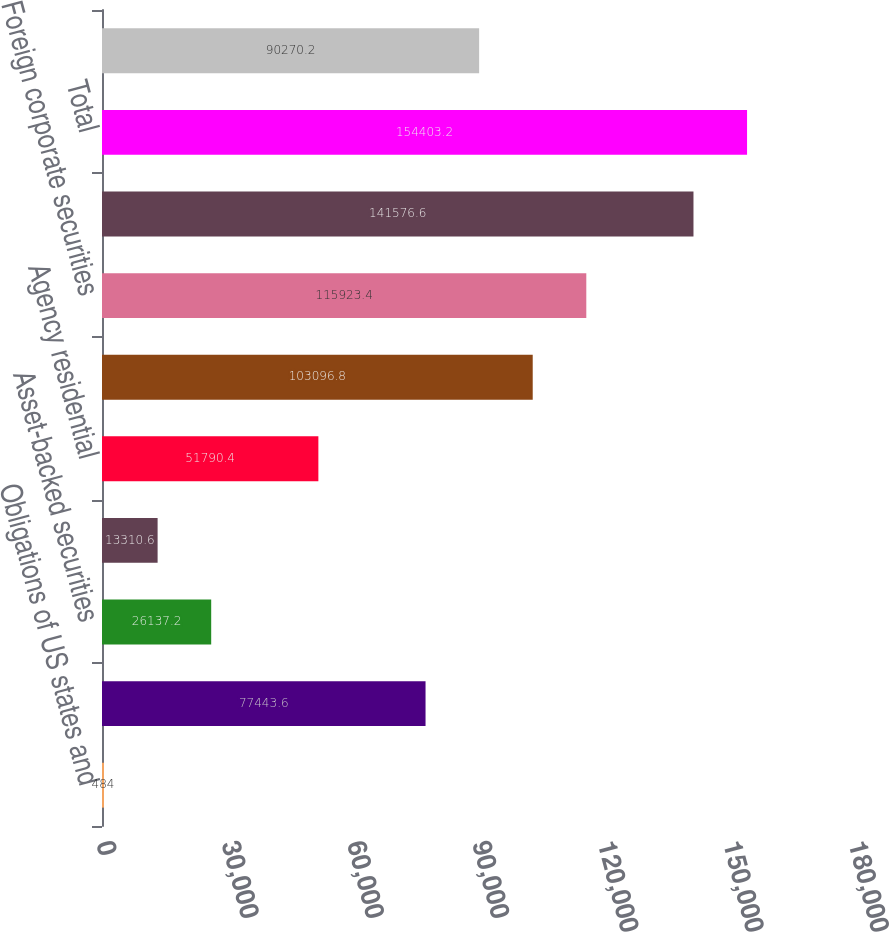Convert chart. <chart><loc_0><loc_0><loc_500><loc_500><bar_chart><fcel>Obligations of US states and<fcel>Corporate securities<fcel>Asset-backed securities<fcel>Commercial<fcel>Agency residential<fcel>Foreign government securities<fcel>Foreign corporate securities<fcel>Total fixed maturity<fcel>Total<fcel>Due in one year or less<nl><fcel>484<fcel>77443.6<fcel>26137.2<fcel>13310.6<fcel>51790.4<fcel>103097<fcel>115923<fcel>141577<fcel>154403<fcel>90270.2<nl></chart> 